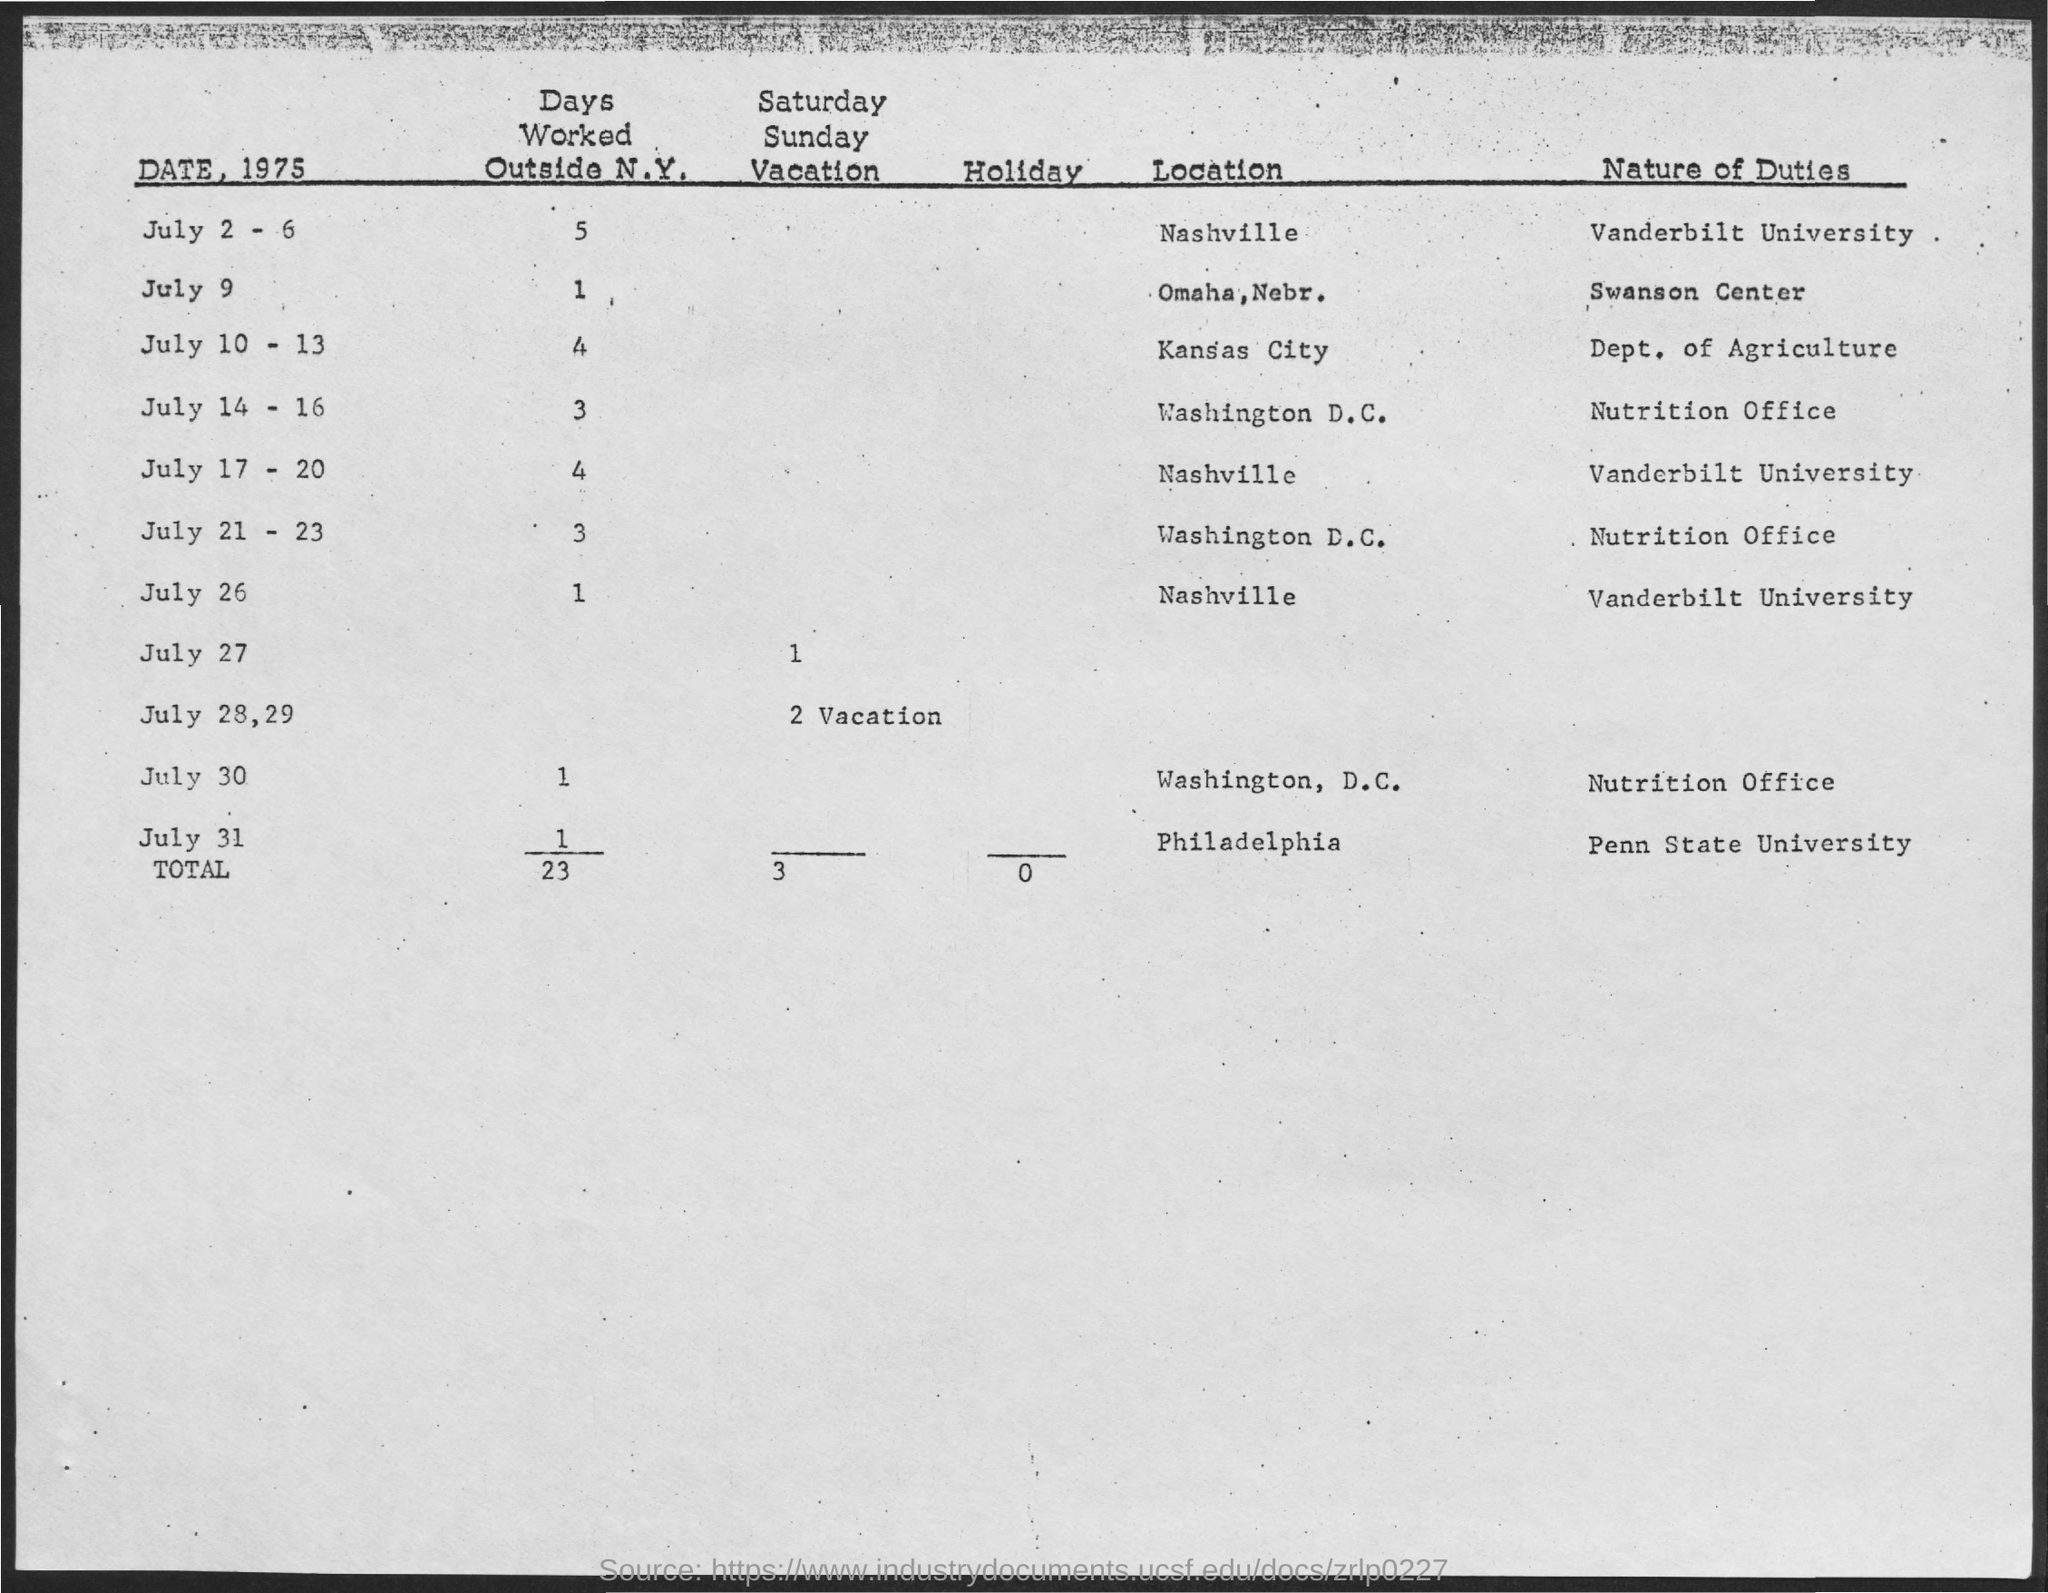What is the total number of days worked outside N.Y.?
Provide a succinct answer. 23. What is the total number of Saturday, Sunday vacations?
Offer a very short reply. 3. What is the total number of Holidays?
Provide a succinct answer. 0. What is the nature of duty on July 9?
Your response must be concise. Swanson center. What is the nature of duty on July 30?
Provide a short and direct response. Nutrition Office. What is the number of days worked outside N.Y. on July 9?
Give a very brief answer. 1. What is the location on July 26?
Provide a short and direct response. Nashville. What is the nature of duty on July 31?
Your answer should be very brief. Penn state university. What is the location on July 21-23?
Offer a terse response. Washington D.C. The nature of duty "Dept. of Agriculture" is on which day?
Your answer should be compact. July 10 - 13. 